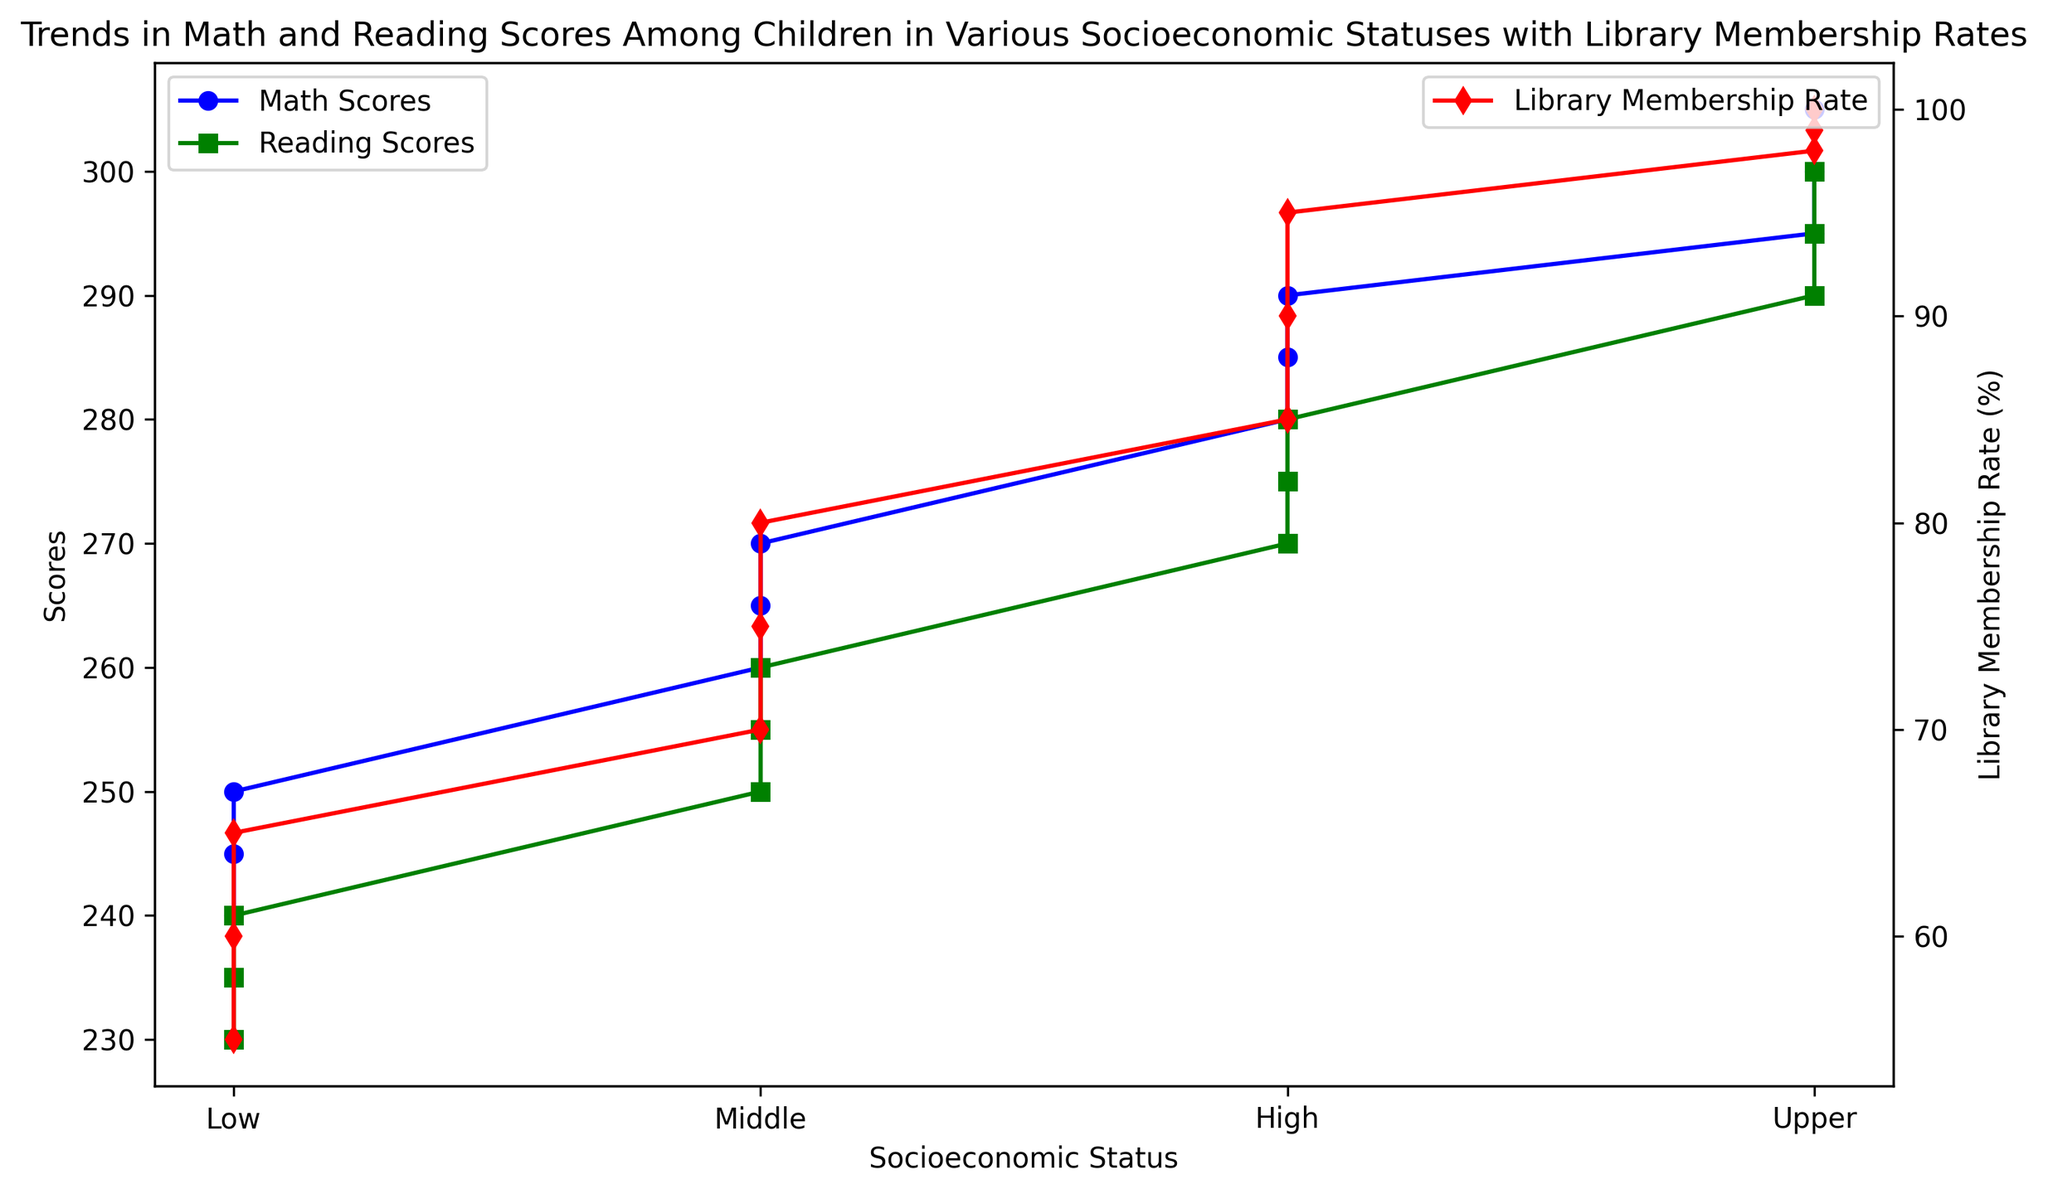How does the Math Scores trend change as Socioeconomic Status increases? As the Socioeconomic Status increases from Low to Upper, Math Scores consistently increase. This is evident from the upward trend of the blue line representing Math Scores.
Answer: Math Scores trend upwards What is the Library Membership Rate for the Middle Socioeconomic Status? For the Middle Socioeconomic Status, the red line representing Library Membership Rate shows rates at 70%, 75%, and 80% respectively.
Answer: 70% to 80% Which Socioeconomic Status has the highest Reading Scores, and what is the score? The Upper Socioeconomic Status has the highest Reading Scores, reaching up to 300, as shown by the green line.
Answer: Upper, 300 What is the difference in Math Scores between the Low and High Socioeconomic Statuses? The Math Scores for Low Socioeconomic Status are between 240 and 250, while for High Socioeconomic Status, they are between 280 and 290. The difference in Math Scores can be calculated as 290 - 250 = 40.
Answer: 40 Are Library Membership Rates higher for High Socioeconomic Status compared to Low Socioeconomic Status? Yes, the Library Membership Rates for Low Socioeconomic Status range from 55% to 65%, whereas for High Socioeconomic Status, they are between 85% and 95%.
Answer: Yes What is the average Math Score for Middle Socioeconomic Status? The Math Scores for the Middle Socioeconomic Status are 260, 265, and 270. The average is calculated as (260 + 265 + 270) / 3 = 265.
Answer: 265 How does the trend of Reading Scores compare to Math Scores across all Socioeconomic Statuses? Both Reading Scores and Math Scores show an upward trend as Socioeconomic Status increases. However, the gap between Reading Scores and Math Scores remains consistent across the different Socioeconomic Statuses as seen from the close proximity of the green and blue lines.
Answer: Upward trend What is the correlation between Math Scores and Library Membership Rate for Upper Socioeconomic Status? For Upper Socioeconomic Status, Math Scores increase from 295 to 305 as Library Membership Rates increase from 98% to 100%. The correlation is positive.
Answer: Positive correlation 